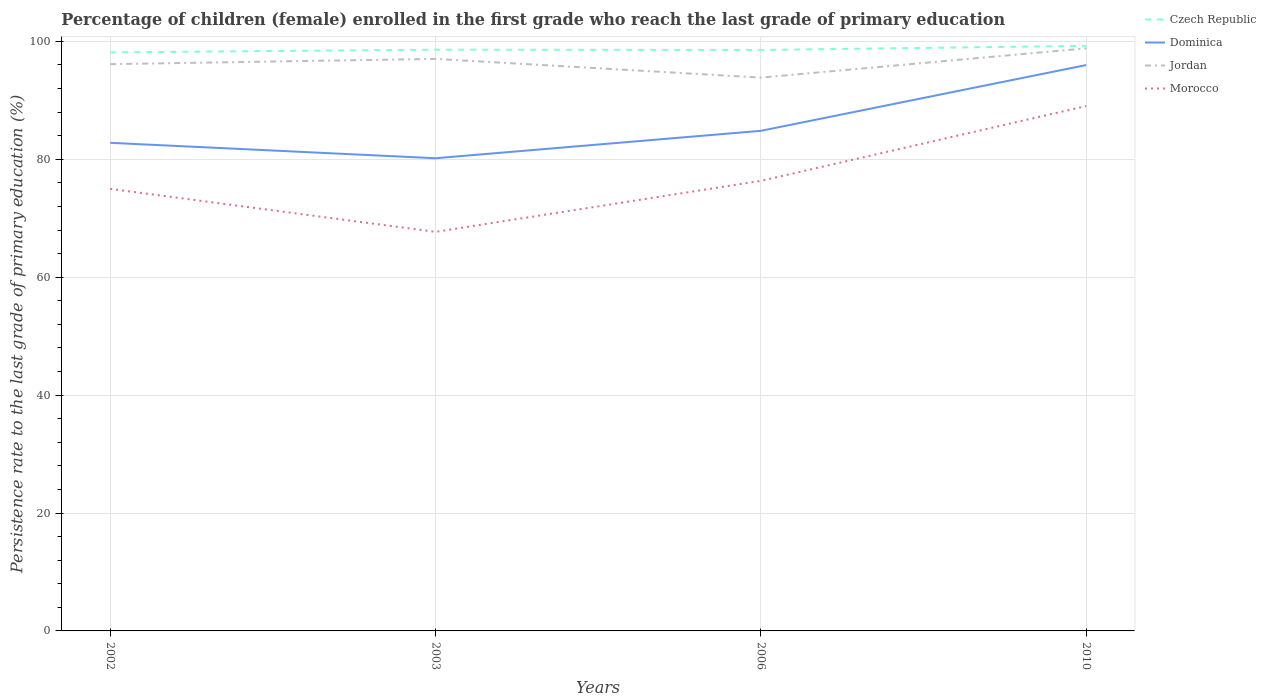Across all years, what is the maximum persistence rate of children in Czech Republic?
Offer a very short reply. 98.13. In which year was the persistence rate of children in Czech Republic maximum?
Your answer should be compact. 2002. What is the total persistence rate of children in Morocco in the graph?
Your response must be concise. -1.36. What is the difference between the highest and the second highest persistence rate of children in Czech Republic?
Ensure brevity in your answer.  1.1. What is the difference between the highest and the lowest persistence rate of children in Czech Republic?
Offer a very short reply. 1. Is the persistence rate of children in Jordan strictly greater than the persistence rate of children in Dominica over the years?
Offer a terse response. No. How many lines are there?
Give a very brief answer. 4. How many years are there in the graph?
Your response must be concise. 4. Does the graph contain grids?
Offer a very short reply. Yes. How many legend labels are there?
Make the answer very short. 4. How are the legend labels stacked?
Provide a succinct answer. Vertical. What is the title of the graph?
Ensure brevity in your answer.  Percentage of children (female) enrolled in the first grade who reach the last grade of primary education. What is the label or title of the Y-axis?
Your response must be concise. Persistence rate to the last grade of primary education (%). What is the Persistence rate to the last grade of primary education (%) in Czech Republic in 2002?
Offer a very short reply. 98.13. What is the Persistence rate to the last grade of primary education (%) of Dominica in 2002?
Ensure brevity in your answer.  82.79. What is the Persistence rate to the last grade of primary education (%) in Jordan in 2002?
Keep it short and to the point. 96.13. What is the Persistence rate to the last grade of primary education (%) in Morocco in 2002?
Your answer should be very brief. 74.98. What is the Persistence rate to the last grade of primary education (%) in Czech Republic in 2003?
Give a very brief answer. 98.59. What is the Persistence rate to the last grade of primary education (%) in Dominica in 2003?
Your answer should be compact. 80.17. What is the Persistence rate to the last grade of primary education (%) of Jordan in 2003?
Keep it short and to the point. 97.02. What is the Persistence rate to the last grade of primary education (%) in Morocco in 2003?
Keep it short and to the point. 67.68. What is the Persistence rate to the last grade of primary education (%) in Czech Republic in 2006?
Make the answer very short. 98.54. What is the Persistence rate to the last grade of primary education (%) in Dominica in 2006?
Give a very brief answer. 84.82. What is the Persistence rate to the last grade of primary education (%) of Jordan in 2006?
Your answer should be very brief. 93.85. What is the Persistence rate to the last grade of primary education (%) of Morocco in 2006?
Provide a succinct answer. 76.34. What is the Persistence rate to the last grade of primary education (%) of Czech Republic in 2010?
Your answer should be compact. 99.23. What is the Persistence rate to the last grade of primary education (%) in Dominica in 2010?
Your answer should be very brief. 95.98. What is the Persistence rate to the last grade of primary education (%) in Jordan in 2010?
Offer a terse response. 98.82. What is the Persistence rate to the last grade of primary education (%) of Morocco in 2010?
Provide a short and direct response. 89.02. Across all years, what is the maximum Persistence rate to the last grade of primary education (%) in Czech Republic?
Give a very brief answer. 99.23. Across all years, what is the maximum Persistence rate to the last grade of primary education (%) in Dominica?
Offer a terse response. 95.98. Across all years, what is the maximum Persistence rate to the last grade of primary education (%) of Jordan?
Offer a terse response. 98.82. Across all years, what is the maximum Persistence rate to the last grade of primary education (%) in Morocco?
Offer a very short reply. 89.02. Across all years, what is the minimum Persistence rate to the last grade of primary education (%) in Czech Republic?
Keep it short and to the point. 98.13. Across all years, what is the minimum Persistence rate to the last grade of primary education (%) in Dominica?
Your answer should be very brief. 80.17. Across all years, what is the minimum Persistence rate to the last grade of primary education (%) in Jordan?
Offer a terse response. 93.85. Across all years, what is the minimum Persistence rate to the last grade of primary education (%) of Morocco?
Provide a short and direct response. 67.68. What is the total Persistence rate to the last grade of primary education (%) in Czech Republic in the graph?
Give a very brief answer. 394.49. What is the total Persistence rate to the last grade of primary education (%) in Dominica in the graph?
Offer a terse response. 343.76. What is the total Persistence rate to the last grade of primary education (%) in Jordan in the graph?
Your response must be concise. 385.82. What is the total Persistence rate to the last grade of primary education (%) in Morocco in the graph?
Ensure brevity in your answer.  308.02. What is the difference between the Persistence rate to the last grade of primary education (%) in Czech Republic in 2002 and that in 2003?
Provide a short and direct response. -0.46. What is the difference between the Persistence rate to the last grade of primary education (%) in Dominica in 2002 and that in 2003?
Provide a short and direct response. 2.62. What is the difference between the Persistence rate to the last grade of primary education (%) of Jordan in 2002 and that in 2003?
Give a very brief answer. -0.89. What is the difference between the Persistence rate to the last grade of primary education (%) in Morocco in 2002 and that in 2003?
Provide a short and direct response. 7.3. What is the difference between the Persistence rate to the last grade of primary education (%) in Czech Republic in 2002 and that in 2006?
Offer a terse response. -0.42. What is the difference between the Persistence rate to the last grade of primary education (%) of Dominica in 2002 and that in 2006?
Offer a terse response. -2.03. What is the difference between the Persistence rate to the last grade of primary education (%) of Jordan in 2002 and that in 2006?
Your answer should be very brief. 2.28. What is the difference between the Persistence rate to the last grade of primary education (%) in Morocco in 2002 and that in 2006?
Provide a short and direct response. -1.36. What is the difference between the Persistence rate to the last grade of primary education (%) in Czech Republic in 2002 and that in 2010?
Make the answer very short. -1.1. What is the difference between the Persistence rate to the last grade of primary education (%) of Dominica in 2002 and that in 2010?
Offer a very short reply. -13.19. What is the difference between the Persistence rate to the last grade of primary education (%) of Jordan in 2002 and that in 2010?
Provide a short and direct response. -2.69. What is the difference between the Persistence rate to the last grade of primary education (%) of Morocco in 2002 and that in 2010?
Keep it short and to the point. -14.04. What is the difference between the Persistence rate to the last grade of primary education (%) in Czech Republic in 2003 and that in 2006?
Your answer should be very brief. 0.04. What is the difference between the Persistence rate to the last grade of primary education (%) in Dominica in 2003 and that in 2006?
Your response must be concise. -4.65. What is the difference between the Persistence rate to the last grade of primary education (%) in Jordan in 2003 and that in 2006?
Make the answer very short. 3.17. What is the difference between the Persistence rate to the last grade of primary education (%) of Morocco in 2003 and that in 2006?
Make the answer very short. -8.65. What is the difference between the Persistence rate to the last grade of primary education (%) in Czech Republic in 2003 and that in 2010?
Keep it short and to the point. -0.64. What is the difference between the Persistence rate to the last grade of primary education (%) of Dominica in 2003 and that in 2010?
Your answer should be very brief. -15.8. What is the difference between the Persistence rate to the last grade of primary education (%) of Jordan in 2003 and that in 2010?
Ensure brevity in your answer.  -1.79. What is the difference between the Persistence rate to the last grade of primary education (%) in Morocco in 2003 and that in 2010?
Ensure brevity in your answer.  -21.34. What is the difference between the Persistence rate to the last grade of primary education (%) in Czech Republic in 2006 and that in 2010?
Offer a very short reply. -0.69. What is the difference between the Persistence rate to the last grade of primary education (%) in Dominica in 2006 and that in 2010?
Make the answer very short. -11.15. What is the difference between the Persistence rate to the last grade of primary education (%) of Jordan in 2006 and that in 2010?
Offer a very short reply. -4.97. What is the difference between the Persistence rate to the last grade of primary education (%) in Morocco in 2006 and that in 2010?
Offer a very short reply. -12.68. What is the difference between the Persistence rate to the last grade of primary education (%) in Czech Republic in 2002 and the Persistence rate to the last grade of primary education (%) in Dominica in 2003?
Your answer should be compact. 17.95. What is the difference between the Persistence rate to the last grade of primary education (%) of Czech Republic in 2002 and the Persistence rate to the last grade of primary education (%) of Jordan in 2003?
Make the answer very short. 1.1. What is the difference between the Persistence rate to the last grade of primary education (%) in Czech Republic in 2002 and the Persistence rate to the last grade of primary education (%) in Morocco in 2003?
Provide a succinct answer. 30.44. What is the difference between the Persistence rate to the last grade of primary education (%) in Dominica in 2002 and the Persistence rate to the last grade of primary education (%) in Jordan in 2003?
Your answer should be compact. -14.23. What is the difference between the Persistence rate to the last grade of primary education (%) in Dominica in 2002 and the Persistence rate to the last grade of primary education (%) in Morocco in 2003?
Offer a very short reply. 15.1. What is the difference between the Persistence rate to the last grade of primary education (%) of Jordan in 2002 and the Persistence rate to the last grade of primary education (%) of Morocco in 2003?
Provide a succinct answer. 28.45. What is the difference between the Persistence rate to the last grade of primary education (%) in Czech Republic in 2002 and the Persistence rate to the last grade of primary education (%) in Dominica in 2006?
Your response must be concise. 13.3. What is the difference between the Persistence rate to the last grade of primary education (%) in Czech Republic in 2002 and the Persistence rate to the last grade of primary education (%) in Jordan in 2006?
Your answer should be very brief. 4.28. What is the difference between the Persistence rate to the last grade of primary education (%) in Czech Republic in 2002 and the Persistence rate to the last grade of primary education (%) in Morocco in 2006?
Your answer should be very brief. 21.79. What is the difference between the Persistence rate to the last grade of primary education (%) in Dominica in 2002 and the Persistence rate to the last grade of primary education (%) in Jordan in 2006?
Make the answer very short. -11.06. What is the difference between the Persistence rate to the last grade of primary education (%) of Dominica in 2002 and the Persistence rate to the last grade of primary education (%) of Morocco in 2006?
Offer a terse response. 6.45. What is the difference between the Persistence rate to the last grade of primary education (%) of Jordan in 2002 and the Persistence rate to the last grade of primary education (%) of Morocco in 2006?
Ensure brevity in your answer.  19.79. What is the difference between the Persistence rate to the last grade of primary education (%) of Czech Republic in 2002 and the Persistence rate to the last grade of primary education (%) of Dominica in 2010?
Your response must be concise. 2.15. What is the difference between the Persistence rate to the last grade of primary education (%) in Czech Republic in 2002 and the Persistence rate to the last grade of primary education (%) in Jordan in 2010?
Your response must be concise. -0.69. What is the difference between the Persistence rate to the last grade of primary education (%) of Czech Republic in 2002 and the Persistence rate to the last grade of primary education (%) of Morocco in 2010?
Your answer should be very brief. 9.11. What is the difference between the Persistence rate to the last grade of primary education (%) of Dominica in 2002 and the Persistence rate to the last grade of primary education (%) of Jordan in 2010?
Keep it short and to the point. -16.03. What is the difference between the Persistence rate to the last grade of primary education (%) of Dominica in 2002 and the Persistence rate to the last grade of primary education (%) of Morocco in 2010?
Your response must be concise. -6.23. What is the difference between the Persistence rate to the last grade of primary education (%) in Jordan in 2002 and the Persistence rate to the last grade of primary education (%) in Morocco in 2010?
Offer a terse response. 7.11. What is the difference between the Persistence rate to the last grade of primary education (%) of Czech Republic in 2003 and the Persistence rate to the last grade of primary education (%) of Dominica in 2006?
Provide a short and direct response. 13.76. What is the difference between the Persistence rate to the last grade of primary education (%) in Czech Republic in 2003 and the Persistence rate to the last grade of primary education (%) in Jordan in 2006?
Offer a very short reply. 4.74. What is the difference between the Persistence rate to the last grade of primary education (%) in Czech Republic in 2003 and the Persistence rate to the last grade of primary education (%) in Morocco in 2006?
Provide a succinct answer. 22.25. What is the difference between the Persistence rate to the last grade of primary education (%) of Dominica in 2003 and the Persistence rate to the last grade of primary education (%) of Jordan in 2006?
Provide a succinct answer. -13.68. What is the difference between the Persistence rate to the last grade of primary education (%) in Dominica in 2003 and the Persistence rate to the last grade of primary education (%) in Morocco in 2006?
Ensure brevity in your answer.  3.84. What is the difference between the Persistence rate to the last grade of primary education (%) of Jordan in 2003 and the Persistence rate to the last grade of primary education (%) of Morocco in 2006?
Keep it short and to the point. 20.69. What is the difference between the Persistence rate to the last grade of primary education (%) in Czech Republic in 2003 and the Persistence rate to the last grade of primary education (%) in Dominica in 2010?
Your answer should be compact. 2.61. What is the difference between the Persistence rate to the last grade of primary education (%) in Czech Republic in 2003 and the Persistence rate to the last grade of primary education (%) in Jordan in 2010?
Ensure brevity in your answer.  -0.23. What is the difference between the Persistence rate to the last grade of primary education (%) in Czech Republic in 2003 and the Persistence rate to the last grade of primary education (%) in Morocco in 2010?
Offer a terse response. 9.57. What is the difference between the Persistence rate to the last grade of primary education (%) of Dominica in 2003 and the Persistence rate to the last grade of primary education (%) of Jordan in 2010?
Provide a short and direct response. -18.64. What is the difference between the Persistence rate to the last grade of primary education (%) of Dominica in 2003 and the Persistence rate to the last grade of primary education (%) of Morocco in 2010?
Give a very brief answer. -8.85. What is the difference between the Persistence rate to the last grade of primary education (%) in Jordan in 2003 and the Persistence rate to the last grade of primary education (%) in Morocco in 2010?
Provide a short and direct response. 8. What is the difference between the Persistence rate to the last grade of primary education (%) of Czech Republic in 2006 and the Persistence rate to the last grade of primary education (%) of Dominica in 2010?
Provide a short and direct response. 2.57. What is the difference between the Persistence rate to the last grade of primary education (%) of Czech Republic in 2006 and the Persistence rate to the last grade of primary education (%) of Jordan in 2010?
Give a very brief answer. -0.27. What is the difference between the Persistence rate to the last grade of primary education (%) of Czech Republic in 2006 and the Persistence rate to the last grade of primary education (%) of Morocco in 2010?
Offer a terse response. 9.52. What is the difference between the Persistence rate to the last grade of primary education (%) in Dominica in 2006 and the Persistence rate to the last grade of primary education (%) in Jordan in 2010?
Make the answer very short. -13.99. What is the difference between the Persistence rate to the last grade of primary education (%) of Dominica in 2006 and the Persistence rate to the last grade of primary education (%) of Morocco in 2010?
Give a very brief answer. -4.2. What is the difference between the Persistence rate to the last grade of primary education (%) of Jordan in 2006 and the Persistence rate to the last grade of primary education (%) of Morocco in 2010?
Your answer should be very brief. 4.83. What is the average Persistence rate to the last grade of primary education (%) in Czech Republic per year?
Provide a short and direct response. 98.62. What is the average Persistence rate to the last grade of primary education (%) of Dominica per year?
Ensure brevity in your answer.  85.94. What is the average Persistence rate to the last grade of primary education (%) of Jordan per year?
Offer a terse response. 96.45. What is the average Persistence rate to the last grade of primary education (%) of Morocco per year?
Ensure brevity in your answer.  77.01. In the year 2002, what is the difference between the Persistence rate to the last grade of primary education (%) of Czech Republic and Persistence rate to the last grade of primary education (%) of Dominica?
Provide a short and direct response. 15.34. In the year 2002, what is the difference between the Persistence rate to the last grade of primary education (%) of Czech Republic and Persistence rate to the last grade of primary education (%) of Jordan?
Ensure brevity in your answer.  2. In the year 2002, what is the difference between the Persistence rate to the last grade of primary education (%) in Czech Republic and Persistence rate to the last grade of primary education (%) in Morocco?
Offer a terse response. 23.14. In the year 2002, what is the difference between the Persistence rate to the last grade of primary education (%) in Dominica and Persistence rate to the last grade of primary education (%) in Jordan?
Your answer should be very brief. -13.34. In the year 2002, what is the difference between the Persistence rate to the last grade of primary education (%) of Dominica and Persistence rate to the last grade of primary education (%) of Morocco?
Provide a succinct answer. 7.81. In the year 2002, what is the difference between the Persistence rate to the last grade of primary education (%) of Jordan and Persistence rate to the last grade of primary education (%) of Morocco?
Offer a very short reply. 21.15. In the year 2003, what is the difference between the Persistence rate to the last grade of primary education (%) in Czech Republic and Persistence rate to the last grade of primary education (%) in Dominica?
Your answer should be very brief. 18.41. In the year 2003, what is the difference between the Persistence rate to the last grade of primary education (%) of Czech Republic and Persistence rate to the last grade of primary education (%) of Jordan?
Your answer should be very brief. 1.56. In the year 2003, what is the difference between the Persistence rate to the last grade of primary education (%) of Czech Republic and Persistence rate to the last grade of primary education (%) of Morocco?
Offer a very short reply. 30.9. In the year 2003, what is the difference between the Persistence rate to the last grade of primary education (%) in Dominica and Persistence rate to the last grade of primary education (%) in Jordan?
Provide a short and direct response. -16.85. In the year 2003, what is the difference between the Persistence rate to the last grade of primary education (%) in Dominica and Persistence rate to the last grade of primary education (%) in Morocco?
Keep it short and to the point. 12.49. In the year 2003, what is the difference between the Persistence rate to the last grade of primary education (%) in Jordan and Persistence rate to the last grade of primary education (%) in Morocco?
Provide a short and direct response. 29.34. In the year 2006, what is the difference between the Persistence rate to the last grade of primary education (%) of Czech Republic and Persistence rate to the last grade of primary education (%) of Dominica?
Your response must be concise. 13.72. In the year 2006, what is the difference between the Persistence rate to the last grade of primary education (%) of Czech Republic and Persistence rate to the last grade of primary education (%) of Jordan?
Ensure brevity in your answer.  4.69. In the year 2006, what is the difference between the Persistence rate to the last grade of primary education (%) in Czech Republic and Persistence rate to the last grade of primary education (%) in Morocco?
Ensure brevity in your answer.  22.2. In the year 2006, what is the difference between the Persistence rate to the last grade of primary education (%) of Dominica and Persistence rate to the last grade of primary education (%) of Jordan?
Offer a very short reply. -9.03. In the year 2006, what is the difference between the Persistence rate to the last grade of primary education (%) in Dominica and Persistence rate to the last grade of primary education (%) in Morocco?
Provide a short and direct response. 8.48. In the year 2006, what is the difference between the Persistence rate to the last grade of primary education (%) in Jordan and Persistence rate to the last grade of primary education (%) in Morocco?
Ensure brevity in your answer.  17.51. In the year 2010, what is the difference between the Persistence rate to the last grade of primary education (%) in Czech Republic and Persistence rate to the last grade of primary education (%) in Dominica?
Provide a succinct answer. 3.25. In the year 2010, what is the difference between the Persistence rate to the last grade of primary education (%) in Czech Republic and Persistence rate to the last grade of primary education (%) in Jordan?
Give a very brief answer. 0.41. In the year 2010, what is the difference between the Persistence rate to the last grade of primary education (%) of Czech Republic and Persistence rate to the last grade of primary education (%) of Morocco?
Give a very brief answer. 10.21. In the year 2010, what is the difference between the Persistence rate to the last grade of primary education (%) in Dominica and Persistence rate to the last grade of primary education (%) in Jordan?
Provide a short and direct response. -2.84. In the year 2010, what is the difference between the Persistence rate to the last grade of primary education (%) in Dominica and Persistence rate to the last grade of primary education (%) in Morocco?
Your answer should be very brief. 6.96. In the year 2010, what is the difference between the Persistence rate to the last grade of primary education (%) in Jordan and Persistence rate to the last grade of primary education (%) in Morocco?
Make the answer very short. 9.8. What is the ratio of the Persistence rate to the last grade of primary education (%) of Czech Republic in 2002 to that in 2003?
Keep it short and to the point. 1. What is the ratio of the Persistence rate to the last grade of primary education (%) of Dominica in 2002 to that in 2003?
Offer a terse response. 1.03. What is the ratio of the Persistence rate to the last grade of primary education (%) in Jordan in 2002 to that in 2003?
Offer a terse response. 0.99. What is the ratio of the Persistence rate to the last grade of primary education (%) of Morocco in 2002 to that in 2003?
Your response must be concise. 1.11. What is the ratio of the Persistence rate to the last grade of primary education (%) in Dominica in 2002 to that in 2006?
Offer a terse response. 0.98. What is the ratio of the Persistence rate to the last grade of primary education (%) of Jordan in 2002 to that in 2006?
Your response must be concise. 1.02. What is the ratio of the Persistence rate to the last grade of primary education (%) in Morocco in 2002 to that in 2006?
Offer a very short reply. 0.98. What is the ratio of the Persistence rate to the last grade of primary education (%) in Czech Republic in 2002 to that in 2010?
Give a very brief answer. 0.99. What is the ratio of the Persistence rate to the last grade of primary education (%) of Dominica in 2002 to that in 2010?
Make the answer very short. 0.86. What is the ratio of the Persistence rate to the last grade of primary education (%) in Jordan in 2002 to that in 2010?
Your response must be concise. 0.97. What is the ratio of the Persistence rate to the last grade of primary education (%) in Morocco in 2002 to that in 2010?
Offer a very short reply. 0.84. What is the ratio of the Persistence rate to the last grade of primary education (%) of Czech Republic in 2003 to that in 2006?
Provide a succinct answer. 1. What is the ratio of the Persistence rate to the last grade of primary education (%) in Dominica in 2003 to that in 2006?
Keep it short and to the point. 0.95. What is the ratio of the Persistence rate to the last grade of primary education (%) of Jordan in 2003 to that in 2006?
Offer a very short reply. 1.03. What is the ratio of the Persistence rate to the last grade of primary education (%) of Morocco in 2003 to that in 2006?
Your answer should be very brief. 0.89. What is the ratio of the Persistence rate to the last grade of primary education (%) of Dominica in 2003 to that in 2010?
Give a very brief answer. 0.84. What is the ratio of the Persistence rate to the last grade of primary education (%) in Jordan in 2003 to that in 2010?
Your answer should be compact. 0.98. What is the ratio of the Persistence rate to the last grade of primary education (%) of Morocco in 2003 to that in 2010?
Offer a very short reply. 0.76. What is the ratio of the Persistence rate to the last grade of primary education (%) of Czech Republic in 2006 to that in 2010?
Provide a succinct answer. 0.99. What is the ratio of the Persistence rate to the last grade of primary education (%) in Dominica in 2006 to that in 2010?
Your answer should be compact. 0.88. What is the ratio of the Persistence rate to the last grade of primary education (%) in Jordan in 2006 to that in 2010?
Your answer should be very brief. 0.95. What is the ratio of the Persistence rate to the last grade of primary education (%) in Morocco in 2006 to that in 2010?
Provide a succinct answer. 0.86. What is the difference between the highest and the second highest Persistence rate to the last grade of primary education (%) in Czech Republic?
Provide a short and direct response. 0.64. What is the difference between the highest and the second highest Persistence rate to the last grade of primary education (%) of Dominica?
Offer a terse response. 11.15. What is the difference between the highest and the second highest Persistence rate to the last grade of primary education (%) of Jordan?
Your answer should be very brief. 1.79. What is the difference between the highest and the second highest Persistence rate to the last grade of primary education (%) of Morocco?
Your answer should be compact. 12.68. What is the difference between the highest and the lowest Persistence rate to the last grade of primary education (%) in Czech Republic?
Give a very brief answer. 1.1. What is the difference between the highest and the lowest Persistence rate to the last grade of primary education (%) of Dominica?
Provide a succinct answer. 15.8. What is the difference between the highest and the lowest Persistence rate to the last grade of primary education (%) in Jordan?
Ensure brevity in your answer.  4.97. What is the difference between the highest and the lowest Persistence rate to the last grade of primary education (%) in Morocco?
Your response must be concise. 21.34. 